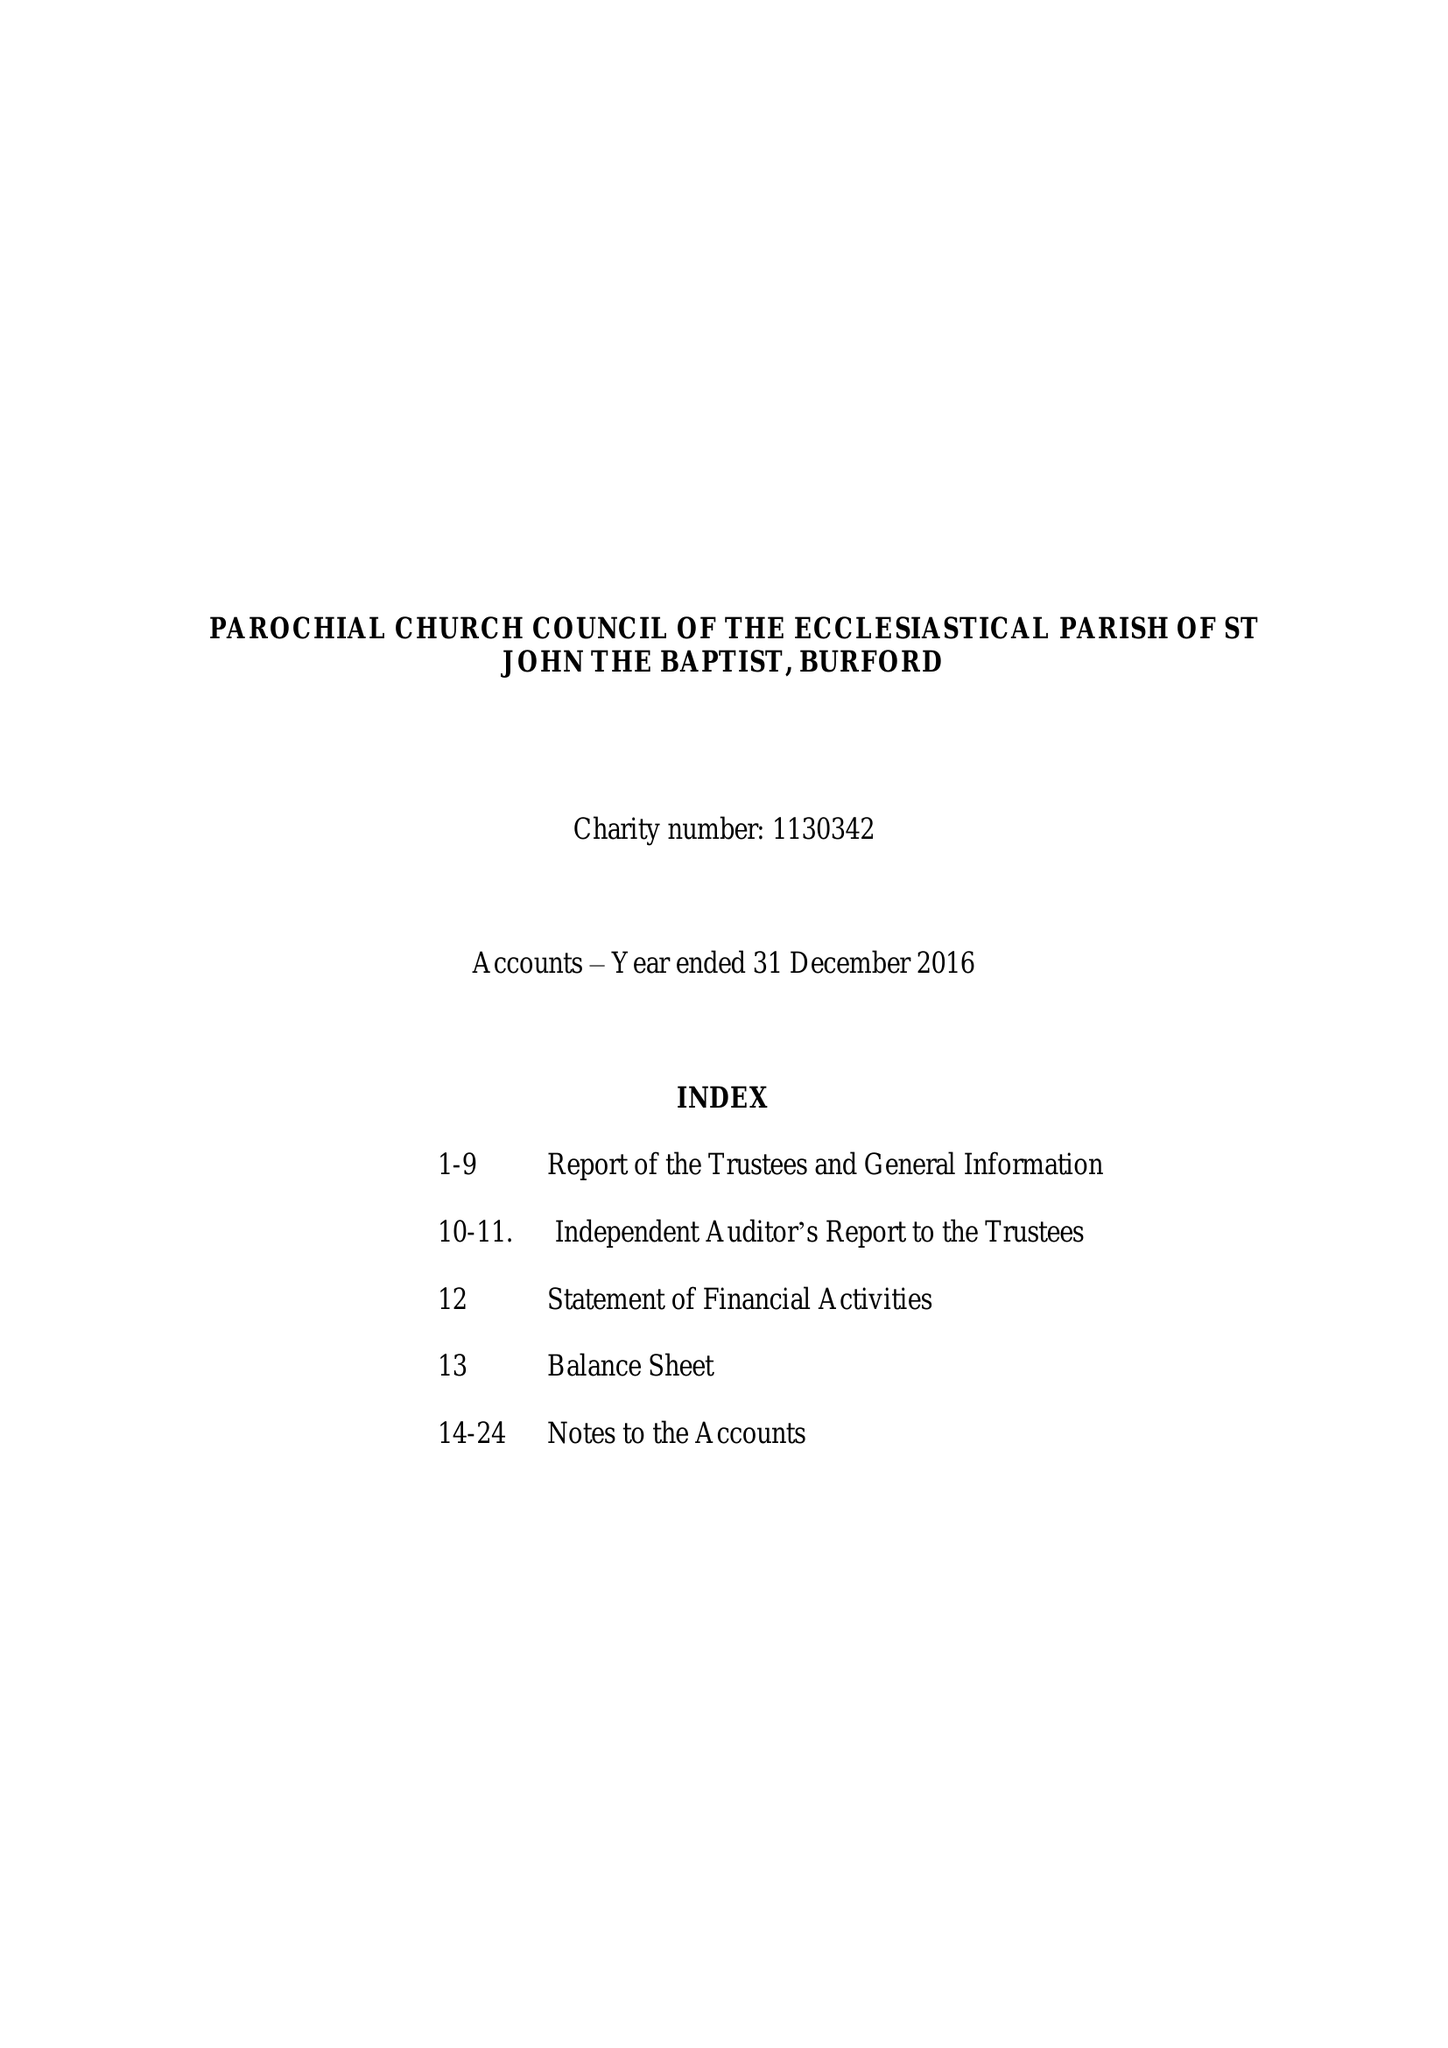What is the value for the address__post_town?
Answer the question using a single word or phrase. CARTERTON 